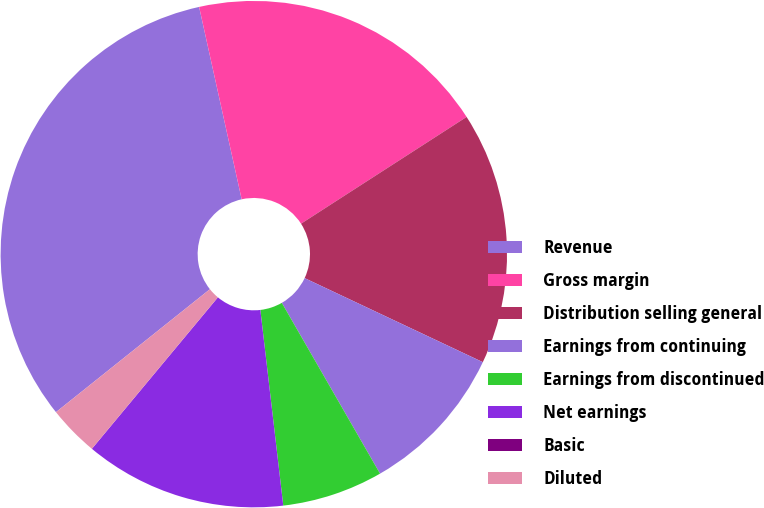<chart> <loc_0><loc_0><loc_500><loc_500><pie_chart><fcel>Revenue<fcel>Gross margin<fcel>Distribution selling general<fcel>Earnings from continuing<fcel>Earnings from discontinued<fcel>Net earnings<fcel>Basic<fcel>Diluted<nl><fcel>32.26%<fcel>19.35%<fcel>16.13%<fcel>9.68%<fcel>6.45%<fcel>12.9%<fcel>0.0%<fcel>3.23%<nl></chart> 